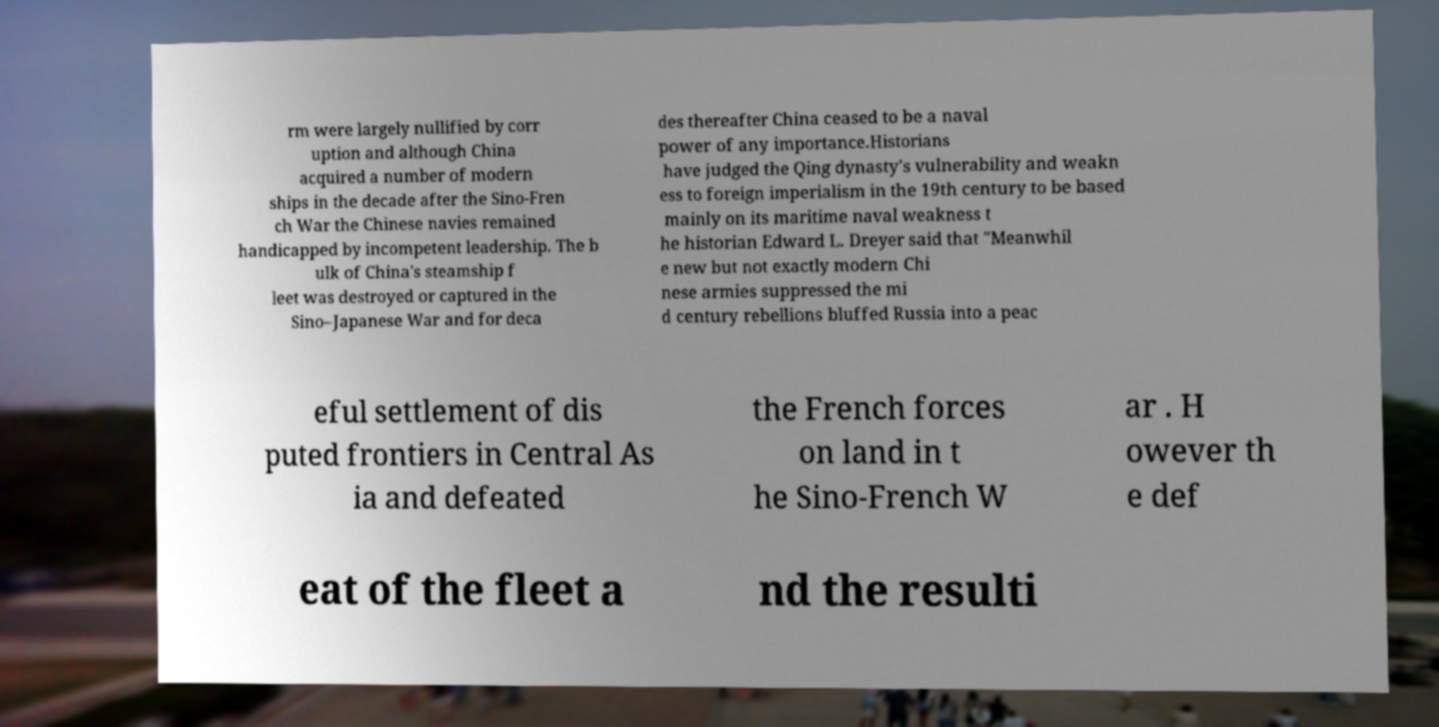Could you extract and type out the text from this image? rm were largely nullified by corr uption and although China acquired a number of modern ships in the decade after the Sino-Fren ch War the Chinese navies remained handicapped by incompetent leadership. The b ulk of China's steamship f leet was destroyed or captured in the Sino–Japanese War and for deca des thereafter China ceased to be a naval power of any importance.Historians have judged the Qing dynasty's vulnerability and weakn ess to foreign imperialism in the 19th century to be based mainly on its maritime naval weakness t he historian Edward L. Dreyer said that "Meanwhil e new but not exactly modern Chi nese armies suppressed the mi d century rebellions bluffed Russia into a peac eful settlement of dis puted frontiers in Central As ia and defeated the French forces on land in t he Sino-French W ar . H owever th e def eat of the fleet a nd the resulti 